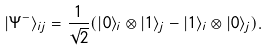<formula> <loc_0><loc_0><loc_500><loc_500>| \Psi ^ { - } \rangle _ { i j } = \frac { 1 } { \sqrt { 2 } } ( | 0 \rangle _ { i } \otimes | 1 \rangle _ { j } - | 1 \rangle _ { i } \otimes | 0 \rangle _ { j } ) .</formula> 